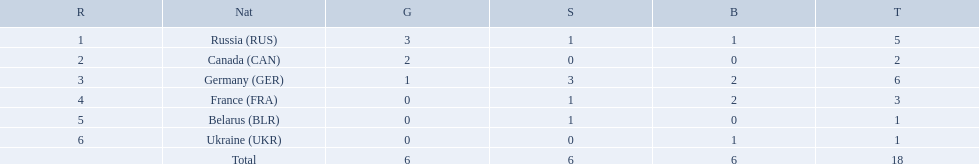Could you help me parse every detail presented in this table? {'header': ['R', 'Nat', 'G', 'S', 'B', 'T'], 'rows': [['1', 'Russia\xa0(RUS)', '3', '1', '1', '5'], ['2', 'Canada\xa0(CAN)', '2', '0', '0', '2'], ['3', 'Germany\xa0(GER)', '1', '3', '2', '6'], ['4', 'France\xa0(FRA)', '0', '1', '2', '3'], ['5', 'Belarus\xa0(BLR)', '0', '1', '0', '1'], ['6', 'Ukraine\xa0(UKR)', '0', '0', '1', '1'], ['', 'Total', '6', '6', '6', '18']]} Name the country that had the same number of bronze medals as russia. Ukraine. 